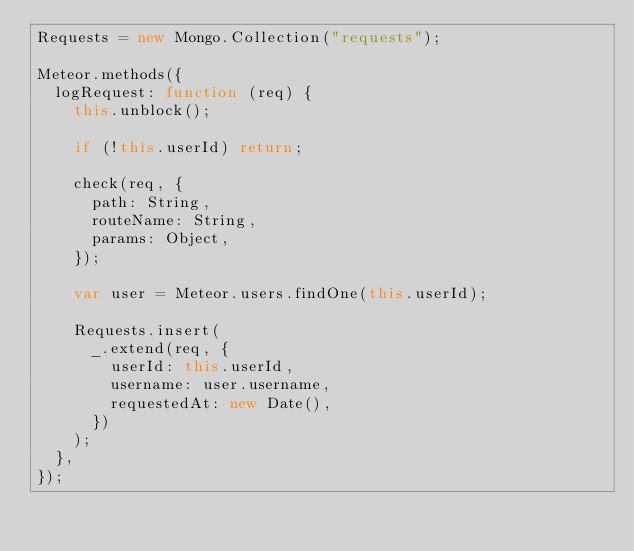Convert code to text. <code><loc_0><loc_0><loc_500><loc_500><_JavaScript_>Requests = new Mongo.Collection("requests");

Meteor.methods({
  logRequest: function (req) {
    this.unblock();

    if (!this.userId) return;

    check(req, {
      path: String,
      routeName: String,
      params: Object,
    });

    var user = Meteor.users.findOne(this.userId);

    Requests.insert(
      _.extend(req, {
        userId: this.userId,
        username: user.username,
        requestedAt: new Date(),
      })
    );
  },
});
</code> 